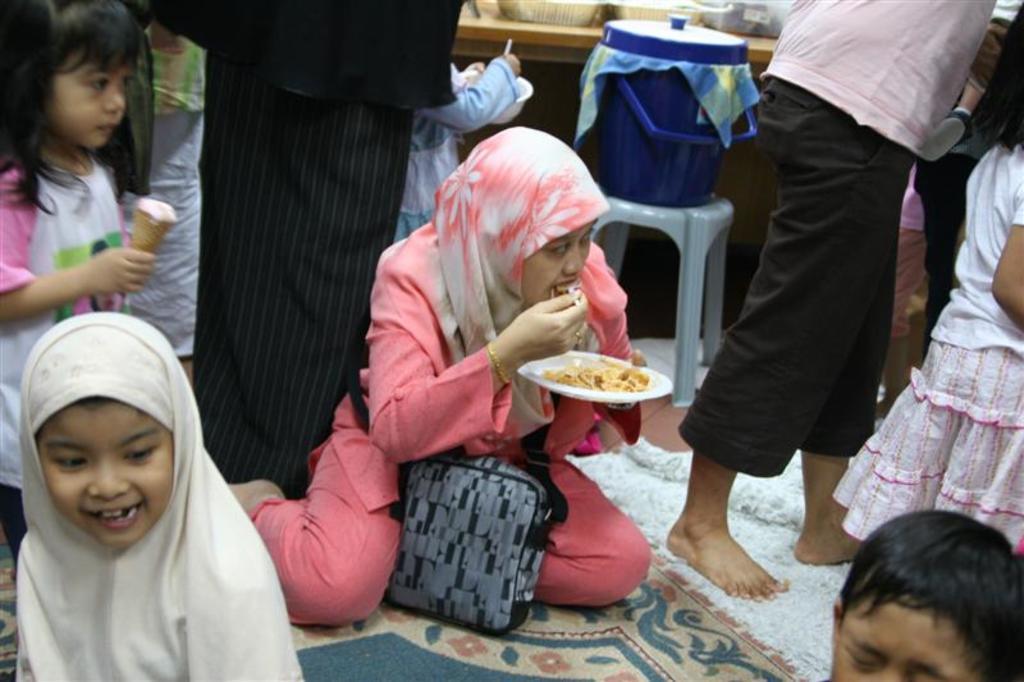In one or two sentences, can you explain what this image depicts? In this picture I can see there is a woman sitting on the floor, she is holding a plate and looking at the right side. There is a kid standing on the right side and there is another girl standing at the left side, she is eating ice cream. There is a person standing behind the woman and there is another man standing beside her. There is a table in the backdrop and there is some food placed on the table and there is a blue color object at the table. 